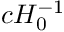<formula> <loc_0><loc_0><loc_500><loc_500>c H _ { 0 } ^ { - 1 }</formula> 